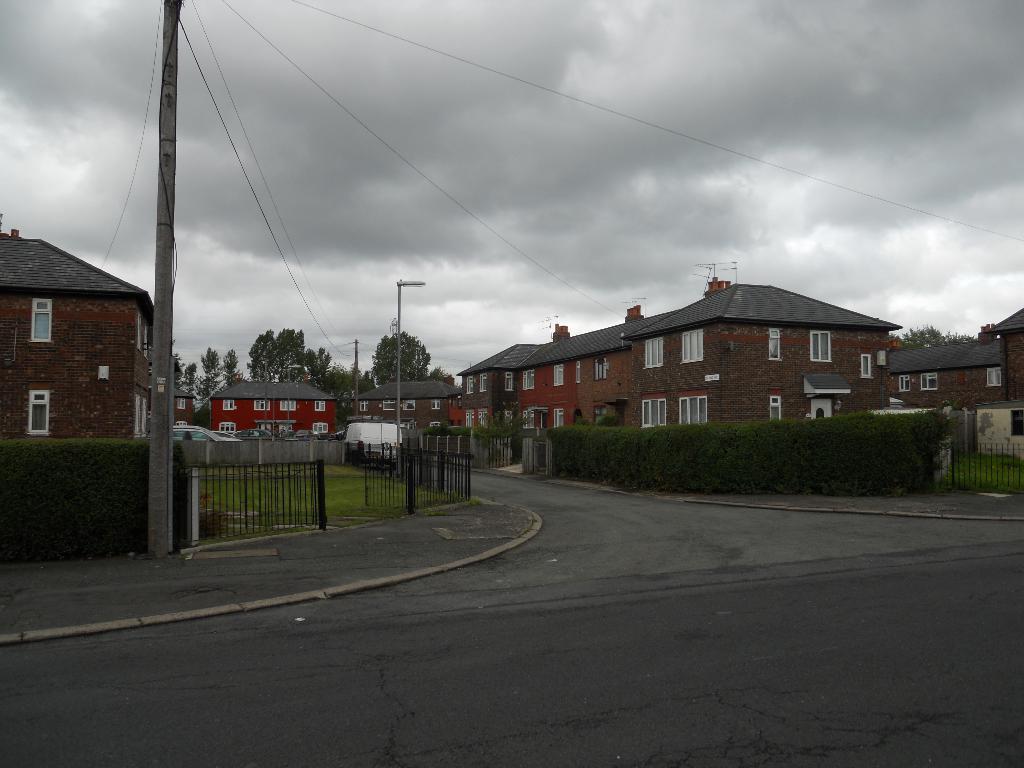Can you describe this image briefly? In this picture we can see the buildings, windows, roofs, trees, poles, grilles, grass, bushes, vehicles. At the bottom of the image we can see the road. At the top of the image we can see the wires and clouds in the sky. 